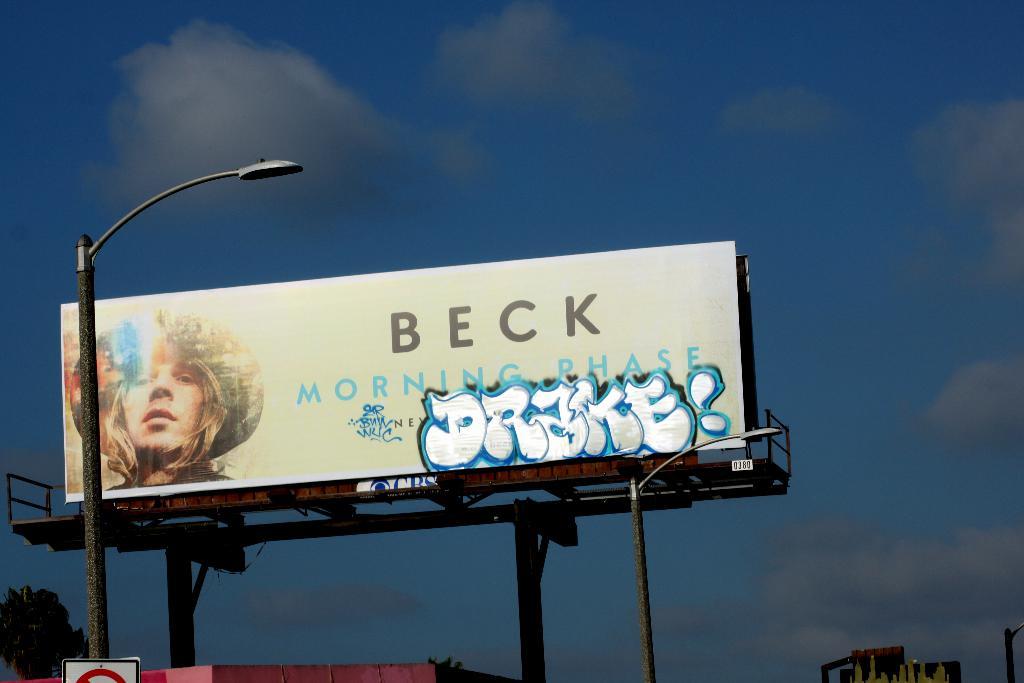Who is the artist on the billboard?
Give a very brief answer. Beck. What does the ad say?
Give a very brief answer. Beck morning phase. 